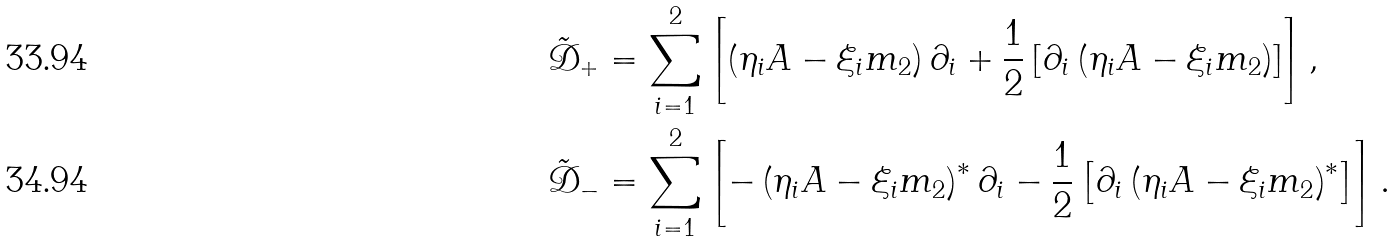Convert formula to latex. <formula><loc_0><loc_0><loc_500><loc_500>\tilde { \mathcal { D } } _ { + } & = \sum _ { i = 1 } ^ { 2 } \left [ \left ( \eta _ { i } A - \xi _ { i } m _ { 2 } \right ) \partial _ { i } + \frac { 1 } { 2 } \left [ \partial _ { i } \left ( \eta _ { i } A - \xi _ { i } m _ { 2 } \right ) \right ] \right ] , \\ \tilde { \mathcal { D } } _ { - } & = \sum _ { i = 1 } ^ { 2 } \left [ - \left ( \eta _ { i } A - \xi _ { i } m _ { 2 } \right ) ^ { * } \partial _ { i } - \frac { 1 } { 2 } \left [ \partial _ { i } \left ( \eta _ { i } A - \xi _ { i } m _ { 2 } \right ) ^ { * } \right ] \right ] .</formula> 